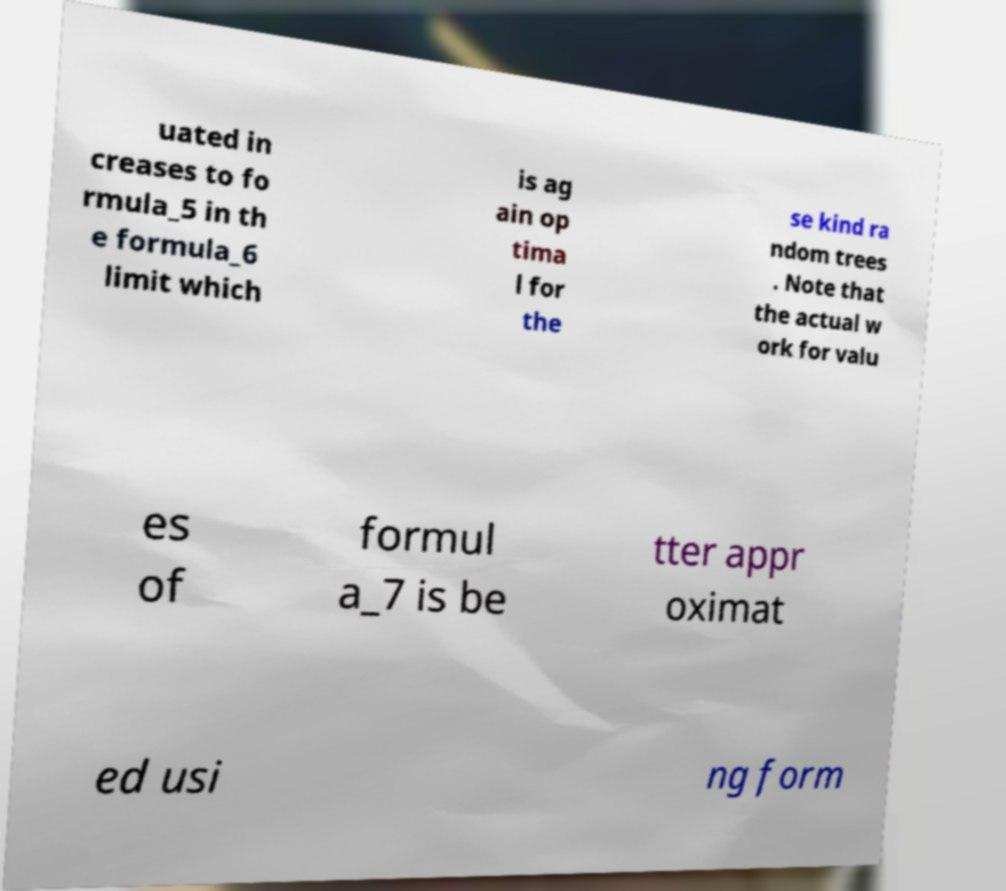There's text embedded in this image that I need extracted. Can you transcribe it verbatim? uated in creases to fo rmula_5 in th e formula_6 limit which is ag ain op tima l for the se kind ra ndom trees . Note that the actual w ork for valu es of formul a_7 is be tter appr oximat ed usi ng form 